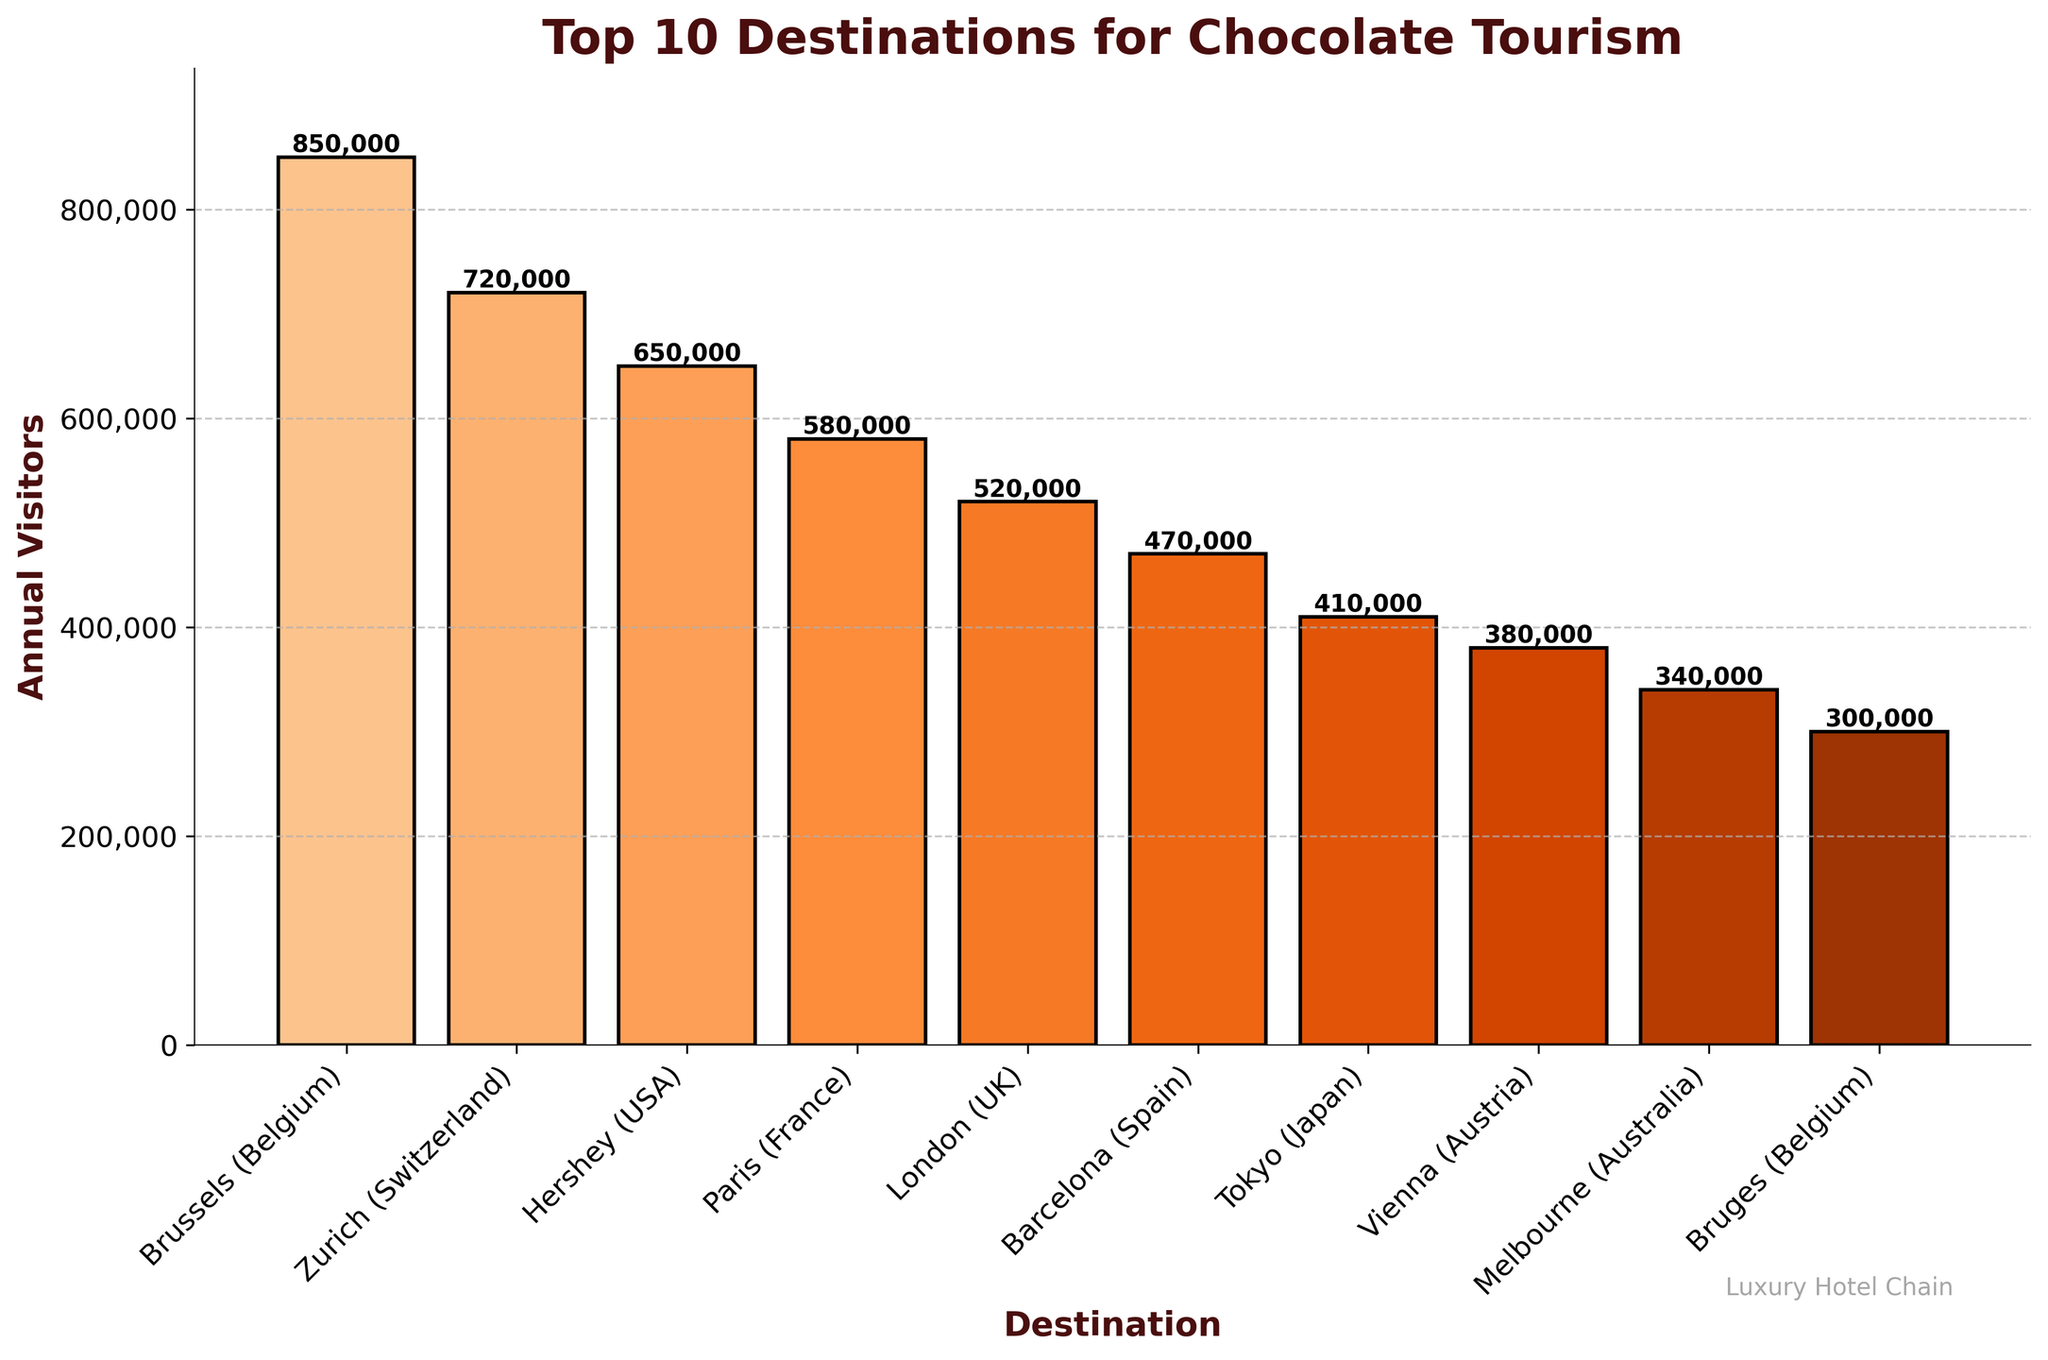Which destination has the highest number of annual visitors? The highest bar represents the destination with the most annual visitors. Brussels (Belgium) has the highest number of annual visitors.
Answer: Brussels (Belgium) Which destination attracts fewer annual visitors, Tokyo (Japan) or Vienna (Austria)? Compare the heights of the bars for both Tokyo and Vienna. Vienna has a higher bar than Tokyo, so Vienna attracts more visitors.
Answer: Tokyo (Japan) What is the total number of annual visitors for the top 3 destinations? Sum the numbers of the top 3 destinations: 850,000 (Brussels) + 720,000 (Zurich) + 650,000 (Hershey).
Answer: 2,220,000 How many visitors does Barcelona (Spain) attract annually? Look at the bar corresponding to Barcelona and read its value. Barcelona attracts 470,000 annual visitors.
Answer: 470,000 Which destination has fewer annual visitors, Melbourne (Australia) or Bruges (Belgium)? Compare the heights of the bars for Melbourne and Bruges. Bruges has a shorter bar than Melbourne, so Bruges attracts fewer visitors.
Answer: Bruges (Belgium) What is the average number of annual visitors for the top 5 destinations? Sum the numbers for the top 5 destinations and divide by 5: (850,000 + 720,000 + 650,000 + 580,000 + 520,000) / 5.
Answer: 664,000 Which destination has more annual visitors, Paris (France) or London (UK)? Compare the heights of the bars for Paris and London. Paris has a higher bar than London, indicating more visitors.
Answer: Paris (France) Which destination is the 7th most visited? Count the bars from the highest to the 7th highest. The 7th bar corresponds to Tokyo (Japan).
Answer: Tokyo (Japan) What is the difference in annual visitors between the top destination and the 10th destination? Subtract the number of annual visitors of the 10th destination from the top destination: 850,000 (Brussels) - 300,000 (Bruges).
Answer: 550,000 How many destinations have more than 500,000 annual visitors? Count the number of bars with values greater than 500,000. There are 5 such destinations: Brussels, Zurich, Hershey, Paris, and London.
Answer: 5 